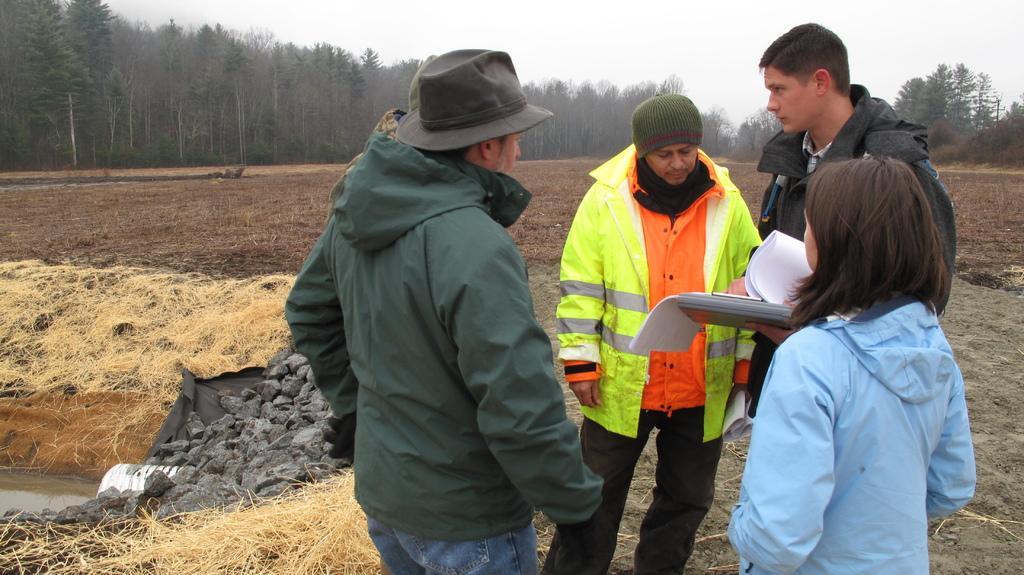In one or two sentences, can you explain what this image depicts? In the picture I can see people are standing among them the man on the right side is holding some objects in the hand. In the background I can see, trees, the grass, the water, rocks and the sky. 